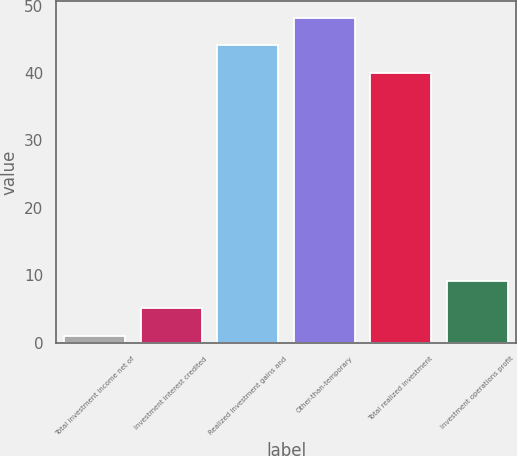Convert chart to OTSL. <chart><loc_0><loc_0><loc_500><loc_500><bar_chart><fcel>Total investment income net of<fcel>Investment interest credited<fcel>Realized investment gains and<fcel>Other-than-temporary<fcel>Total realized investment<fcel>Investment operations profit<nl><fcel>1<fcel>5.1<fcel>44.1<fcel>48.2<fcel>40<fcel>9.2<nl></chart> 